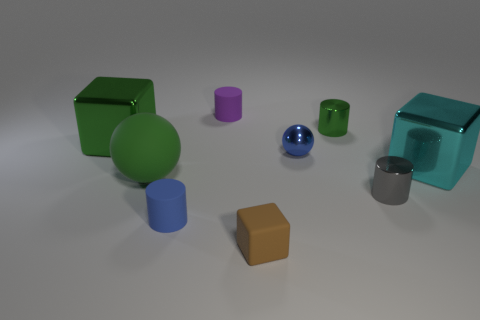There is a purple object that is the same size as the blue shiny sphere; what is its material?
Your answer should be compact. Rubber. There is a green thing on the right side of the rubber block; what size is it?
Keep it short and to the point. Small. There is a matte cylinder that is behind the tiny blue metal thing; does it have the same size as the green metallic object on the left side of the tiny blue matte cylinder?
Make the answer very short. No. What number of tiny blue things are the same material as the big cyan object?
Provide a succinct answer. 1. The matte block is what color?
Your answer should be very brief. Brown. Are there any cyan objects to the left of the matte cube?
Keep it short and to the point. No. Does the large rubber ball have the same color as the small block?
Offer a very short reply. No. How many big blocks have the same color as the large rubber ball?
Keep it short and to the point. 1. What size is the green object to the right of the blue thing in front of the shiny sphere?
Make the answer very short. Small. What is the shape of the small purple object?
Offer a terse response. Cylinder. 